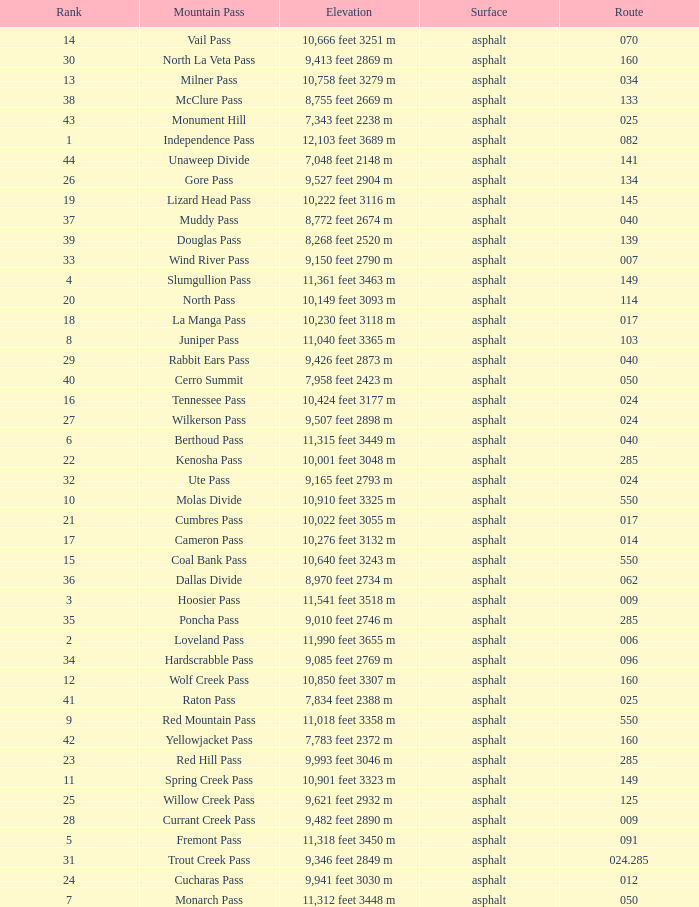What is the Elevation of the mountain on Route 62? 8,970 feet 2734 m. 